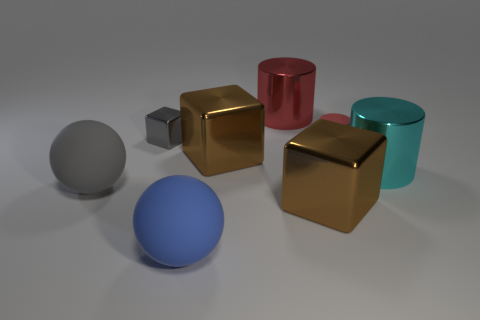Subtract all brown cubes. How many were subtracted if there are1brown cubes left? 1 Add 1 small gray things. How many objects exist? 9 Subtract all spheres. How many objects are left? 6 Add 3 large shiny cubes. How many large shiny cubes exist? 5 Subtract 1 blue spheres. How many objects are left? 7 Subtract all big rubber balls. Subtract all green matte cylinders. How many objects are left? 6 Add 1 brown cubes. How many brown cubes are left? 3 